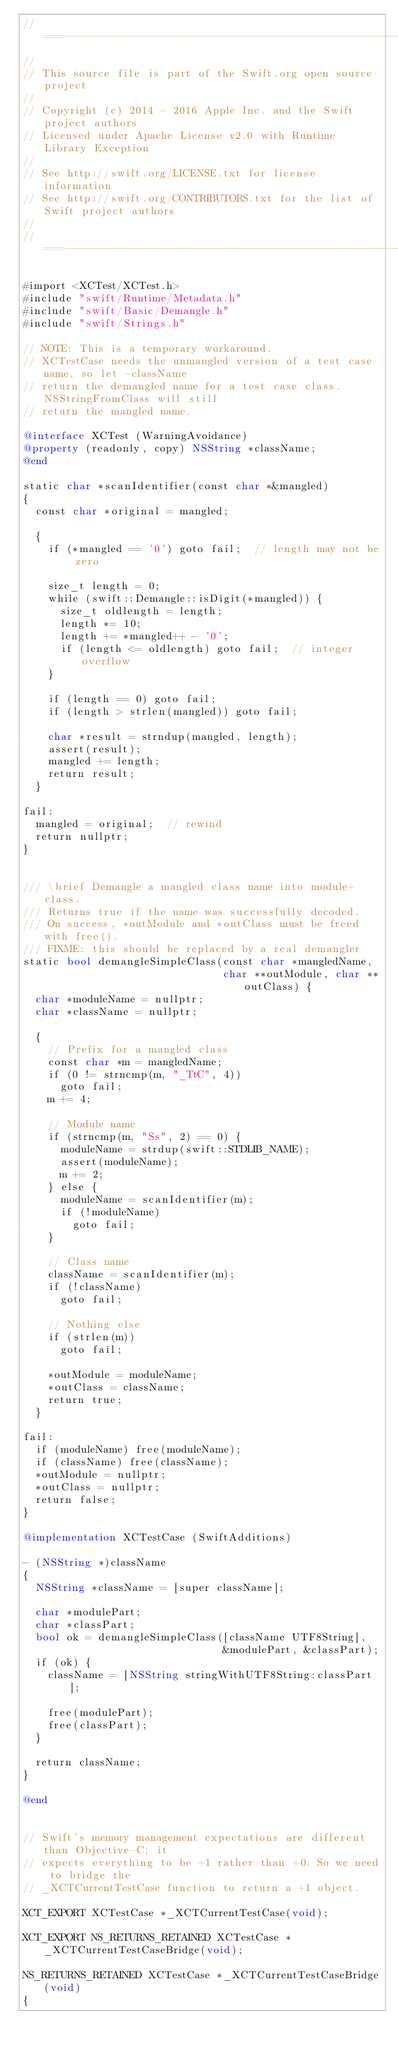<code> <loc_0><loc_0><loc_500><loc_500><_ObjectiveC_>//===----------------------------------------------------------------------===//
//
// This source file is part of the Swift.org open source project
//
// Copyright (c) 2014 - 2016 Apple Inc. and the Swift project authors
// Licensed under Apache License v2.0 with Runtime Library Exception
//
// See http://swift.org/LICENSE.txt for license information
// See http://swift.org/CONTRIBUTORS.txt for the list of Swift project authors
//
//===----------------------------------------------------------------------===//

#import <XCTest/XCTest.h>
#include "swift/Runtime/Metadata.h"
#include "swift/Basic/Demangle.h"
#include "swift/Strings.h"

// NOTE: This is a temporary workaround.
// XCTestCase needs the unmangled version of a test case name, so let -className
// return the demangled name for a test case class. NSStringFromClass will still
// return the mangled name.

@interface XCTest (WarningAvoidance)
@property (readonly, copy) NSString *className;
@end

static char *scanIdentifier(const char *&mangled)
{
  const char *original = mangled;

  {
    if (*mangled == '0') goto fail;  // length may not be zero

    size_t length = 0;
    while (swift::Demangle::isDigit(*mangled)) {
      size_t oldlength = length;
      length *= 10;
      length += *mangled++ - '0';
      if (length <= oldlength) goto fail;  // integer overflow
    }

    if (length == 0) goto fail;
    if (length > strlen(mangled)) goto fail;

    char *result = strndup(mangled, length);
    assert(result);
    mangled += length;
    return result;
  }

fail:
  mangled = original;  // rewind
  return nullptr;
}


/// \brief Demangle a mangled class name into module+class.
/// Returns true if the name was successfully decoded.
/// On success, *outModule and *outClass must be freed with free().
/// FIXME: this should be replaced by a real demangler
static bool demangleSimpleClass(const char *mangledName,
                                char **outModule, char **outClass) {
  char *moduleName = nullptr;
  char *className = nullptr;

  {
    // Prefix for a mangled class
    const char *m = mangledName;
    if (0 != strncmp(m, "_TtC", 4))
      goto fail;
    m += 4;

    // Module name
    if (strncmp(m, "Ss", 2) == 0) {
      moduleName = strdup(swift::STDLIB_NAME);
      assert(moduleName);
      m += 2;
    } else {
      moduleName = scanIdentifier(m);
      if (!moduleName)
        goto fail;
    }

    // Class name
    className = scanIdentifier(m);
    if (!className)
      goto fail;

    // Nothing else
    if (strlen(m))
      goto fail;

    *outModule = moduleName;
    *outClass = className;
    return true;
  }

fail:
  if (moduleName) free(moduleName);
  if (className) free(className);
  *outModule = nullptr;
  *outClass = nullptr;
  return false;
}

@implementation XCTestCase (SwiftAdditions)

- (NSString *)className
{
  NSString *className = [super className];
  
  char *modulePart;
  char *classPart;
  bool ok = demangleSimpleClass([className UTF8String],
                                &modulePart, &classPart);
  if (ok) {
    className = [NSString stringWithUTF8String:classPart];
    
    free(modulePart);
    free(classPart);
  }
  
  return className;
}

@end


// Swift's memory management expectations are different than Objective-C; it
// expects everything to be +1 rather than +0. So we need to bridge the
// _XCTCurrentTestCase function to return a +1 object.

XCT_EXPORT XCTestCase *_XCTCurrentTestCase(void);

XCT_EXPORT NS_RETURNS_RETAINED XCTestCase *_XCTCurrentTestCaseBridge(void);

NS_RETURNS_RETAINED XCTestCase *_XCTCurrentTestCaseBridge(void)
{</code> 